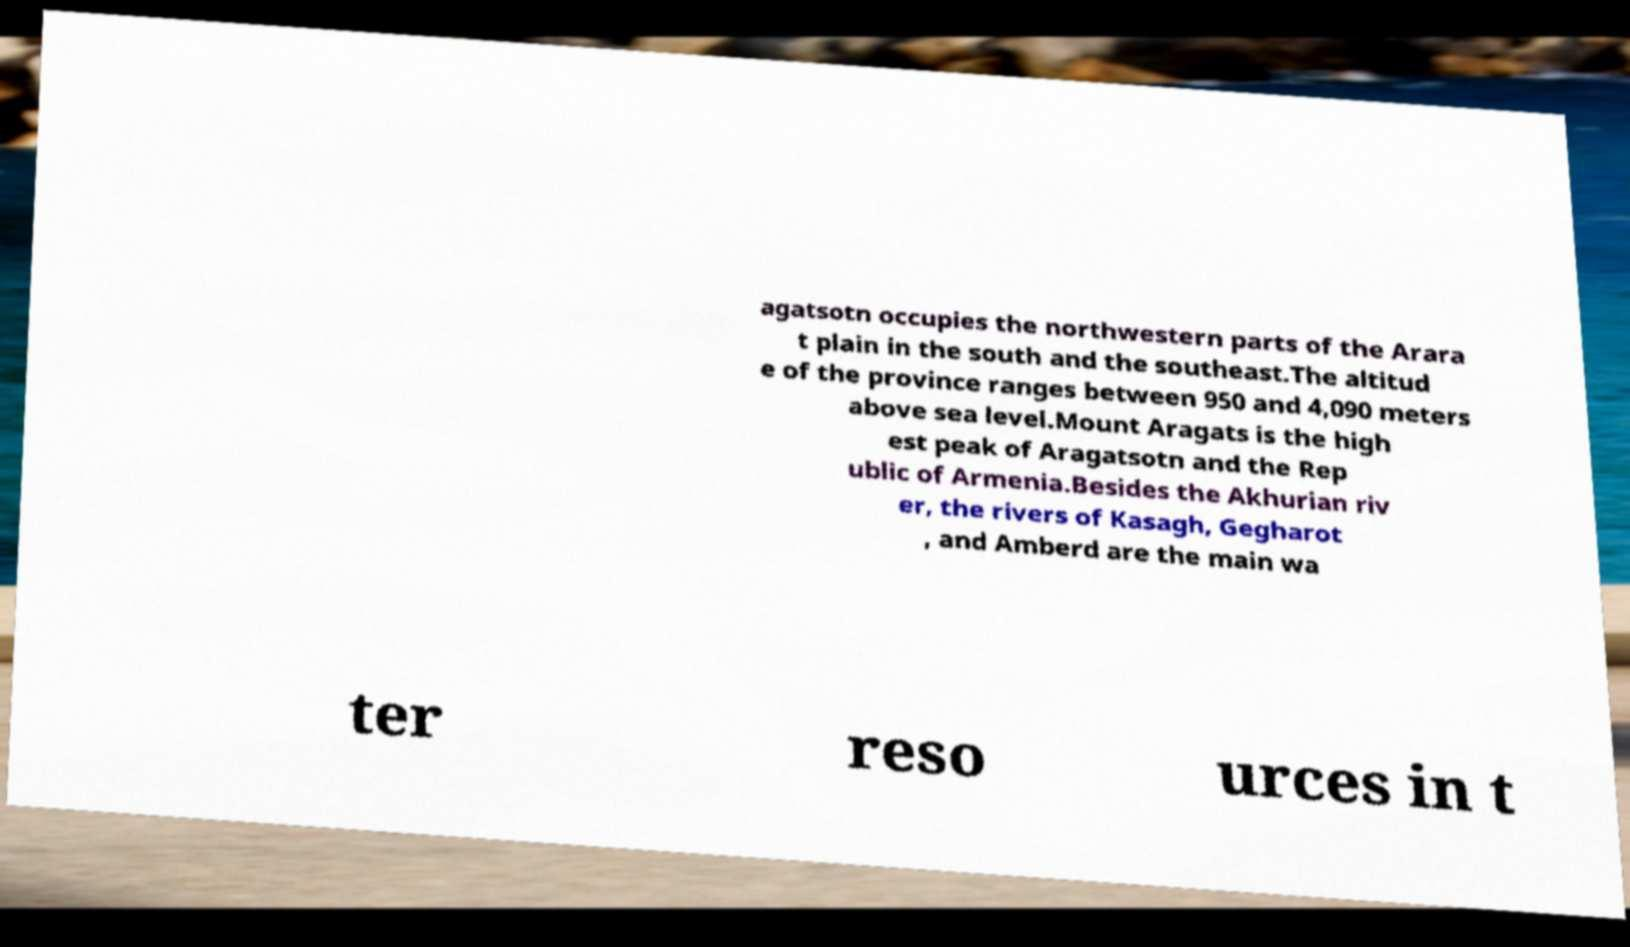Can you read and provide the text displayed in the image?This photo seems to have some interesting text. Can you extract and type it out for me? agatsotn occupies the northwestern parts of the Arara t plain in the south and the southeast.The altitud e of the province ranges between 950 and 4,090 meters above sea level.Mount Aragats is the high est peak of Aragatsotn and the Rep ublic of Armenia.Besides the Akhurian riv er, the rivers of Kasagh, Gegharot , and Amberd are the main wa ter reso urces in t 